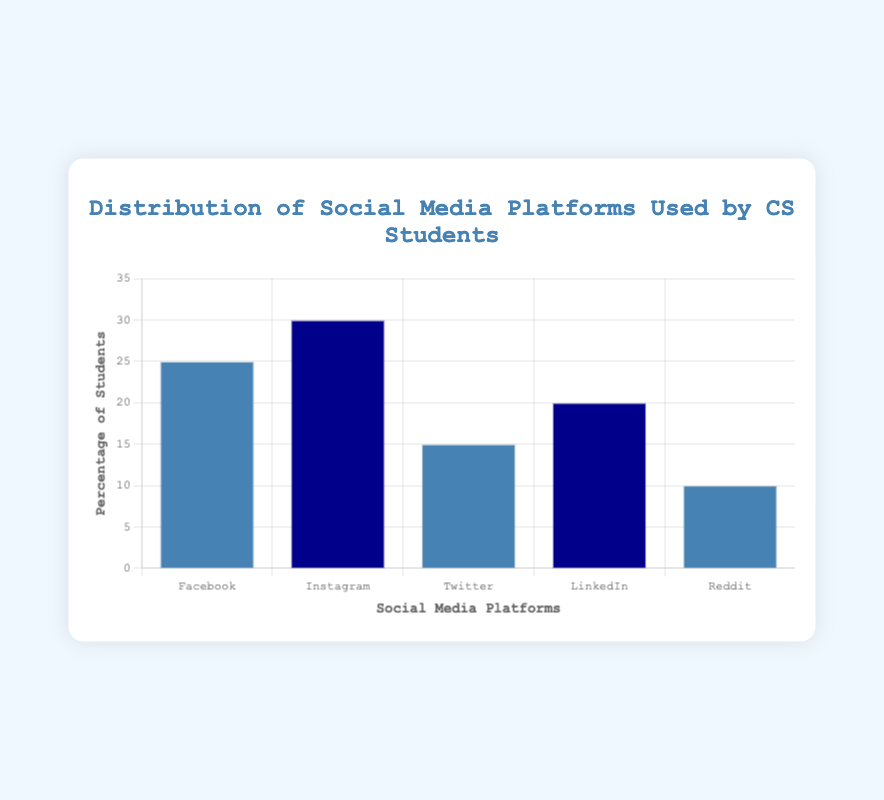Which social media platform is used by the highest percentage of computer science students? Look at the heights of the bars to see which one is the tallest, indicating the highest percentage. Instagram has the tallest bar at 30%.
Answer: Instagram Which social media platform is used by the lowest percentage of computer science students? Look at the heights of the bars to see which one is the lowest, indicating the lowest percentage. Reddit has the shortest bar at 10%.
Answer: Reddit What is the total percentage of students using Facebook, Twitter, and LinkedIn combined? Add the percentages of students using Facebook (25%), Twitter (15%), and LinkedIn (20%). 25 + 15 + 20 = 60.
Answer: 60% Are there more computer science students using Instagram or LinkedIn? Compare the heights of the bars for Instagram and LinkedIn. Instagram's bar is taller at 30% compared to LinkedIn's 20%.
Answer: Instagram What is the difference in the percentage of students using Instagram and Reddit? Subtract the percentage of students using Reddit (10%) from the percentage of students using Instagram (30%). 30 - 10 = 20.
Answer: 20% Which social media platforms have similar usage percentages? Compare the heights of the bars to see which ones are close in height. Facebook (25%) and LinkedIn (20%) are the closest in percentage.
Answer: Facebook and LinkedIn What is the average percentage of students using Facebook, Instagram, and Twitter? Add the percentages of students using Facebook (25%), Instagram (30%), and Twitter (15%), and then divide by 3. (25 + 30 + 15) / 3 = 23.33.
Answer: 23.33% How does the usage of Facebook compare to the combined usage of Twitter and Reddit? Sum the percentages of Twitter (15%) and Reddit (10%), then compare to Facebook's percentage (25%). Twitter + Reddit = 15 + 10 = 25, which is equal to Facebook's 25%.
Answer: Equal What is the cumulative percentage of students using all the listed social media platforms? Add the percentages of students using Facebook (25%), Instagram (30%), Twitter (15%), LinkedIn (20%), and Reddit (10%). 25 + 30 + 15 + 20 + 10 = 100.
Answer: 100% What is the percentage difference between the most popular and least popular social media platforms? Subtract the percentage of students using the least popular platform, Reddit (10%), from the percentage of the most popular platform, Instagram (30%). 30 - 10 = 20.
Answer: 20% 